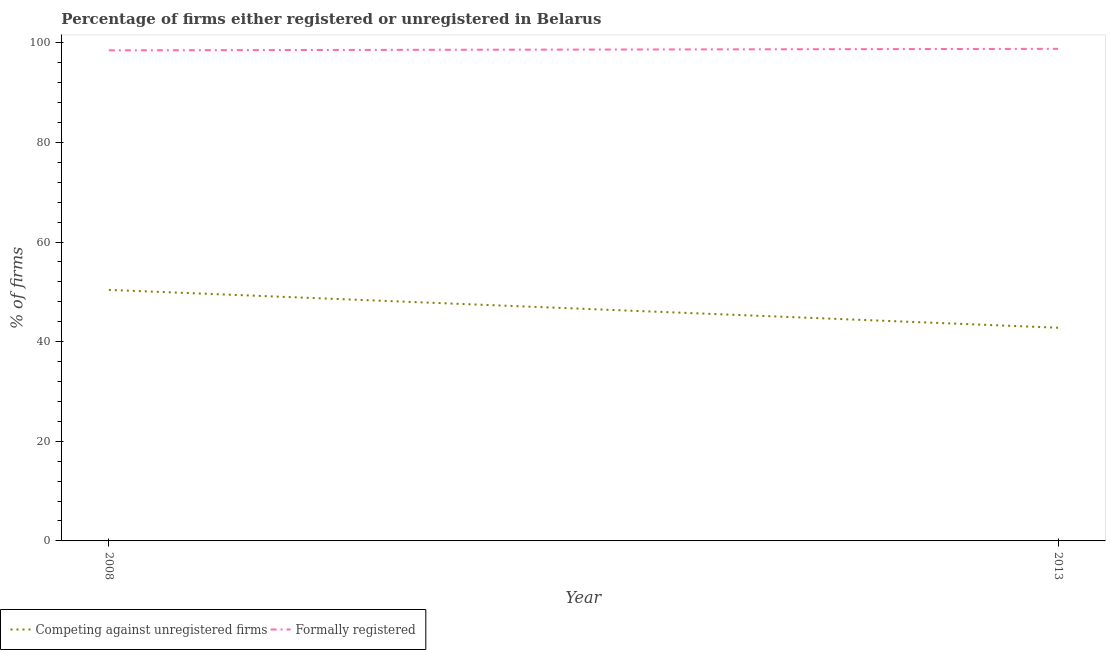Does the line corresponding to percentage of registered firms intersect with the line corresponding to percentage of formally registered firms?
Give a very brief answer. No. Is the number of lines equal to the number of legend labels?
Give a very brief answer. Yes. What is the percentage of registered firms in 2008?
Provide a short and direct response. 50.4. Across all years, what is the maximum percentage of registered firms?
Keep it short and to the point. 50.4. Across all years, what is the minimum percentage of formally registered firms?
Give a very brief answer. 98.5. In which year was the percentage of formally registered firms maximum?
Your answer should be compact. 2013. In which year was the percentage of formally registered firms minimum?
Offer a very short reply. 2008. What is the total percentage of registered firms in the graph?
Give a very brief answer. 93.2. What is the difference between the percentage of formally registered firms in 2008 and that in 2013?
Your answer should be very brief. -0.3. What is the difference between the percentage of registered firms in 2013 and the percentage of formally registered firms in 2008?
Ensure brevity in your answer.  -55.7. What is the average percentage of formally registered firms per year?
Provide a short and direct response. 98.65. In how many years, is the percentage of formally registered firms greater than 8 %?
Keep it short and to the point. 2. What is the ratio of the percentage of formally registered firms in 2008 to that in 2013?
Offer a terse response. 1. In how many years, is the percentage of formally registered firms greater than the average percentage of formally registered firms taken over all years?
Provide a succinct answer. 1. How many years are there in the graph?
Your answer should be very brief. 2. What is the difference between two consecutive major ticks on the Y-axis?
Your response must be concise. 20. Are the values on the major ticks of Y-axis written in scientific E-notation?
Your answer should be very brief. No. How many legend labels are there?
Give a very brief answer. 2. What is the title of the graph?
Offer a very short reply. Percentage of firms either registered or unregistered in Belarus. What is the label or title of the X-axis?
Ensure brevity in your answer.  Year. What is the label or title of the Y-axis?
Your answer should be compact. % of firms. What is the % of firms of Competing against unregistered firms in 2008?
Your answer should be very brief. 50.4. What is the % of firms in Formally registered in 2008?
Ensure brevity in your answer.  98.5. What is the % of firms of Competing against unregistered firms in 2013?
Keep it short and to the point. 42.8. What is the % of firms of Formally registered in 2013?
Offer a terse response. 98.8. Across all years, what is the maximum % of firms of Competing against unregistered firms?
Offer a very short reply. 50.4. Across all years, what is the maximum % of firms in Formally registered?
Keep it short and to the point. 98.8. Across all years, what is the minimum % of firms of Competing against unregistered firms?
Ensure brevity in your answer.  42.8. Across all years, what is the minimum % of firms in Formally registered?
Offer a terse response. 98.5. What is the total % of firms of Competing against unregistered firms in the graph?
Provide a short and direct response. 93.2. What is the total % of firms in Formally registered in the graph?
Your response must be concise. 197.3. What is the difference between the % of firms of Competing against unregistered firms in 2008 and the % of firms of Formally registered in 2013?
Ensure brevity in your answer.  -48.4. What is the average % of firms of Competing against unregistered firms per year?
Make the answer very short. 46.6. What is the average % of firms of Formally registered per year?
Offer a terse response. 98.65. In the year 2008, what is the difference between the % of firms in Competing against unregistered firms and % of firms in Formally registered?
Keep it short and to the point. -48.1. In the year 2013, what is the difference between the % of firms in Competing against unregistered firms and % of firms in Formally registered?
Your response must be concise. -56. What is the ratio of the % of firms in Competing against unregistered firms in 2008 to that in 2013?
Provide a succinct answer. 1.18. What is the ratio of the % of firms in Formally registered in 2008 to that in 2013?
Ensure brevity in your answer.  1. What is the difference between the highest and the second highest % of firms of Competing against unregistered firms?
Make the answer very short. 7.6. What is the difference between the highest and the second highest % of firms in Formally registered?
Your response must be concise. 0.3. What is the difference between the highest and the lowest % of firms in Competing against unregistered firms?
Your answer should be very brief. 7.6. 